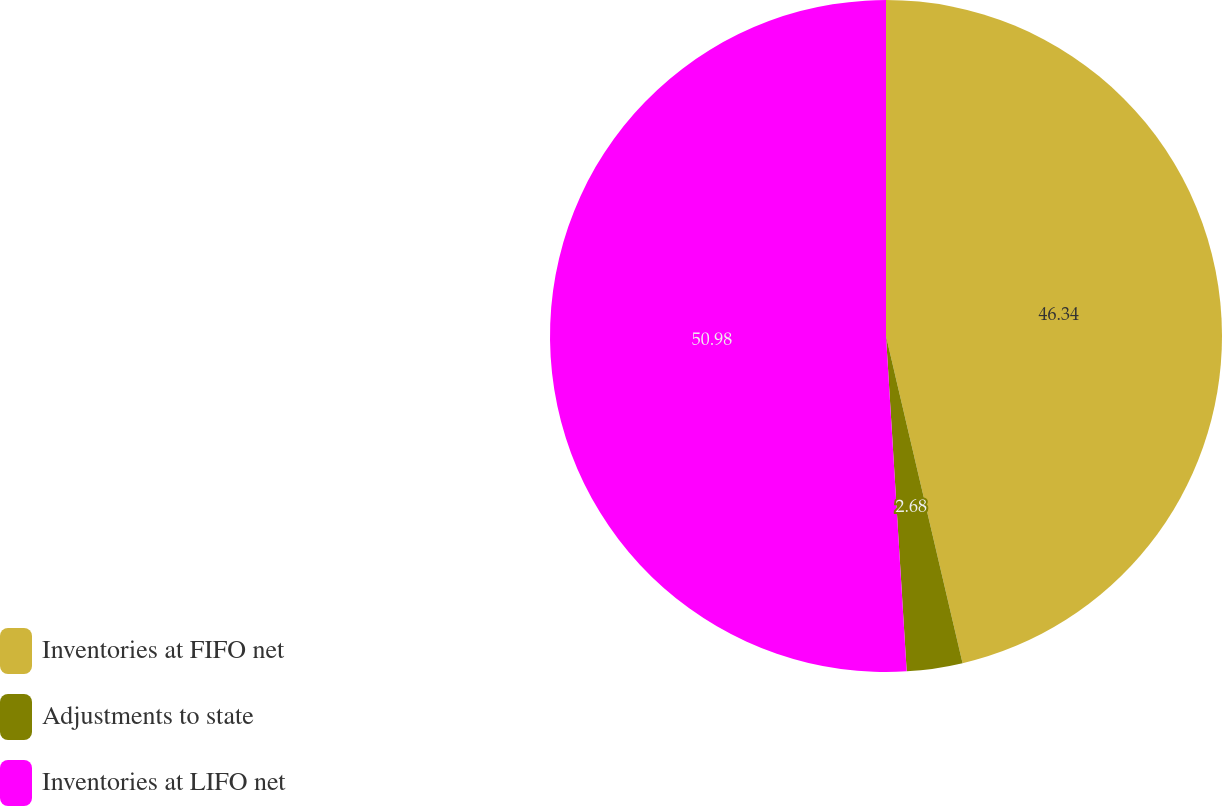<chart> <loc_0><loc_0><loc_500><loc_500><pie_chart><fcel>Inventories at FIFO net<fcel>Adjustments to state<fcel>Inventories at LIFO net<nl><fcel>46.34%<fcel>2.68%<fcel>50.98%<nl></chart> 